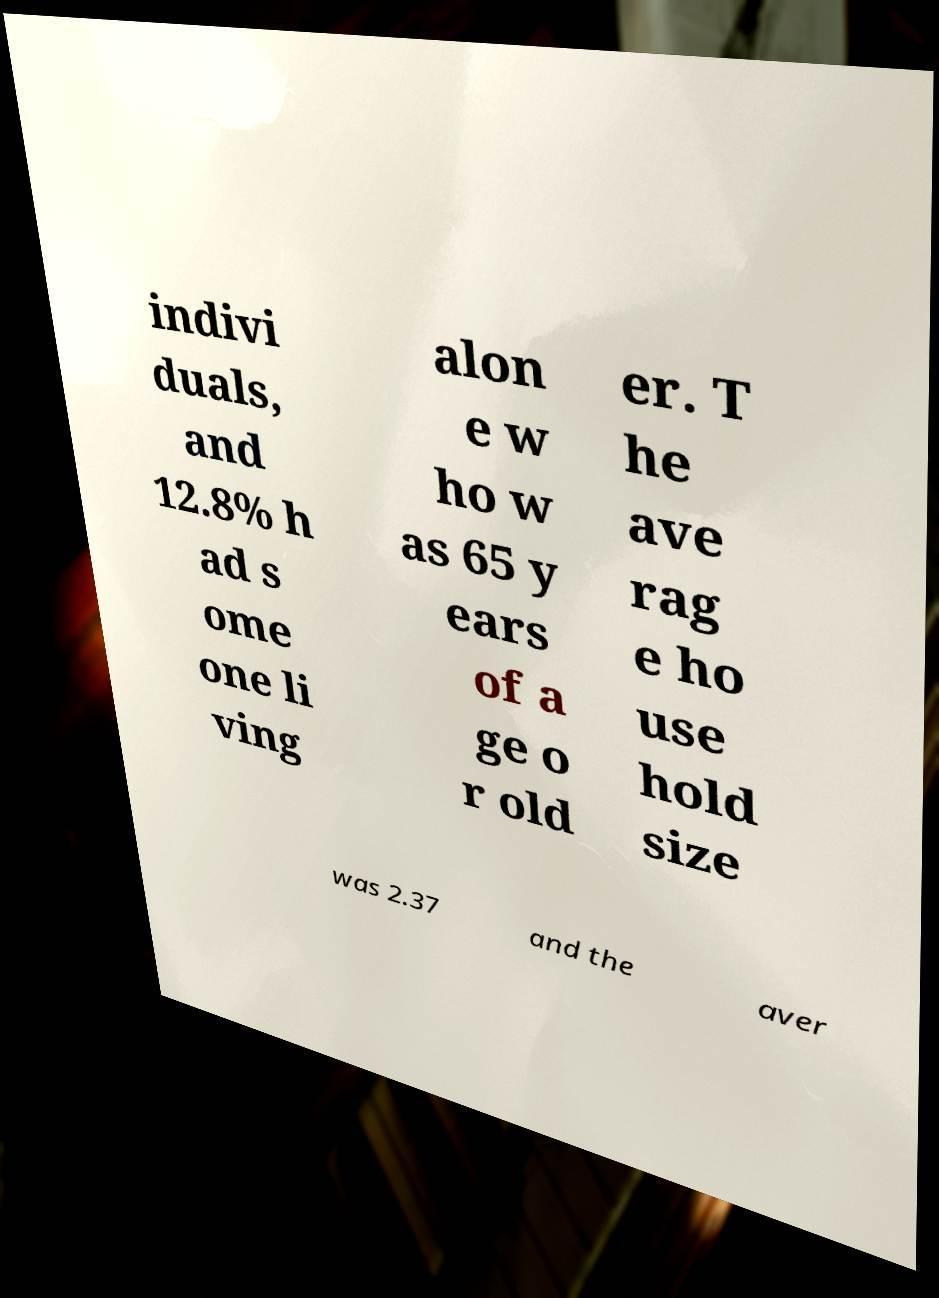Please read and relay the text visible in this image. What does it say? indivi duals, and 12.8% h ad s ome one li ving alon e w ho w as 65 y ears of a ge o r old er. T he ave rag e ho use hold size was 2.37 and the aver 